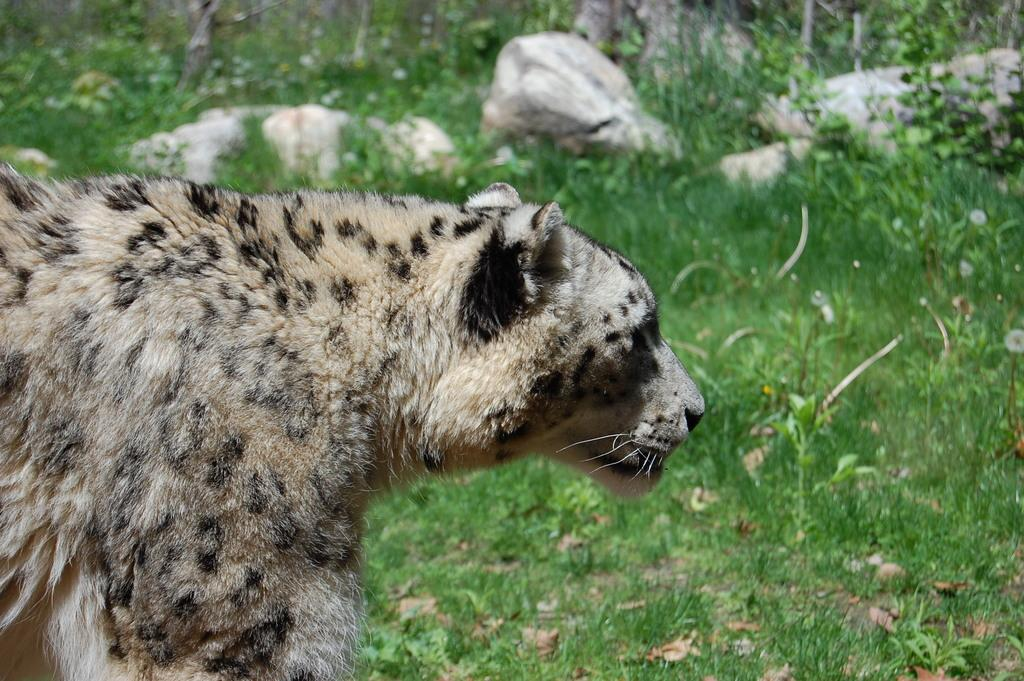What animal is in the front of the image? There is a snow leopard in the front of the image. What type of vegetation can be seen in the background of the image? There is grass and plants in the background of the image. What other natural elements are present in the background of the image? Rocks are present in the background of the image. What decision is the snow leopard making in the image? The image does not depict the snow leopard making a decision, as it is a still photograph. What subject is the snow leopard teaching in the image? The image does not depict the snow leopard teaching any subject, as it is a still photograph of the animal in its natural habitat. 